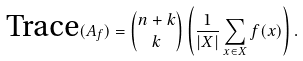Convert formula to latex. <formula><loc_0><loc_0><loc_500><loc_500>\text {Trace} ( A _ { f } ) = { n + k \choose k } \left ( \frac { 1 } { | X | } \sum _ { x \in X } f ( x ) \right ) .</formula> 